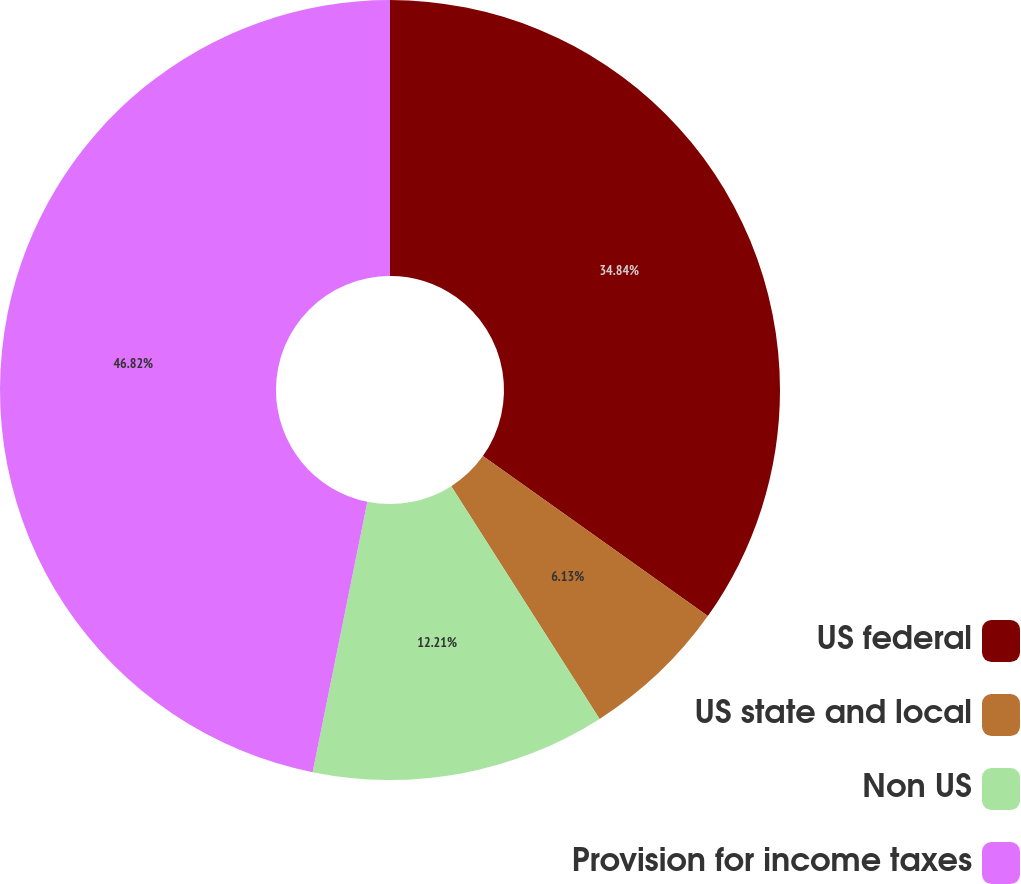Convert chart. <chart><loc_0><loc_0><loc_500><loc_500><pie_chart><fcel>US federal<fcel>US state and local<fcel>Non US<fcel>Provision for income taxes<nl><fcel>34.84%<fcel>6.13%<fcel>12.21%<fcel>46.82%<nl></chart> 